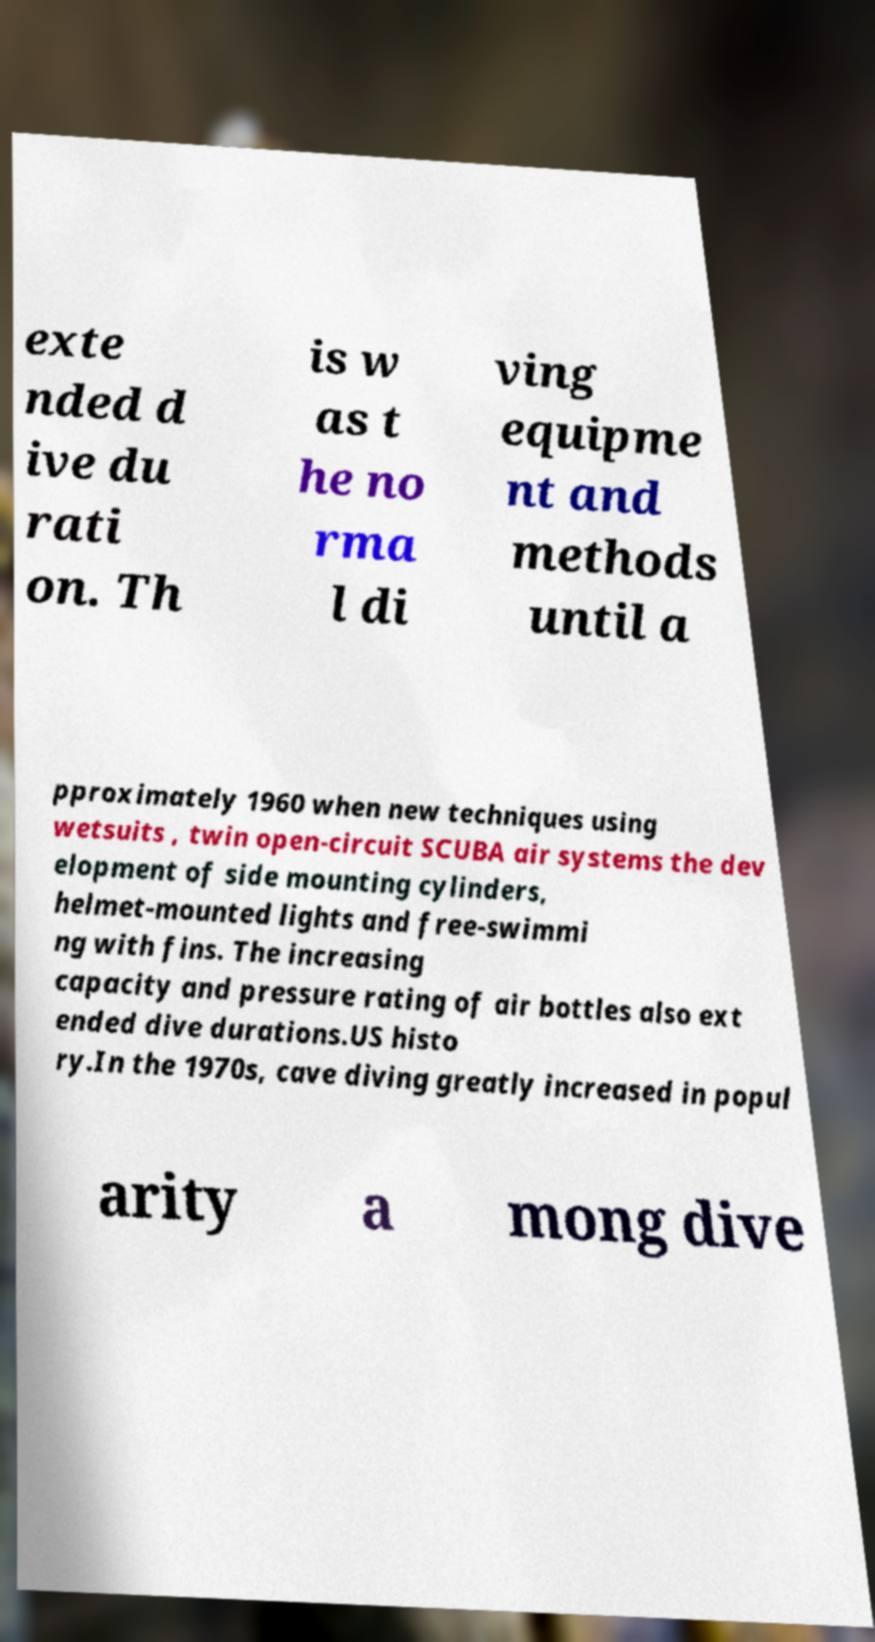Could you extract and type out the text from this image? exte nded d ive du rati on. Th is w as t he no rma l di ving equipme nt and methods until a pproximately 1960 when new techniques using wetsuits , twin open-circuit SCUBA air systems the dev elopment of side mounting cylinders, helmet-mounted lights and free-swimmi ng with fins. The increasing capacity and pressure rating of air bottles also ext ended dive durations.US histo ry.In the 1970s, cave diving greatly increased in popul arity a mong dive 